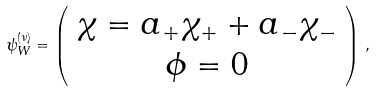<formula> <loc_0><loc_0><loc_500><loc_500>\psi ^ { ( \nu ) } _ { W } = \left ( \begin{array} { c } \chi = a _ { + } \chi _ { + } + a _ { - } \chi _ { - } \\ \phi = 0 \end{array} \right ) \, ,</formula> 